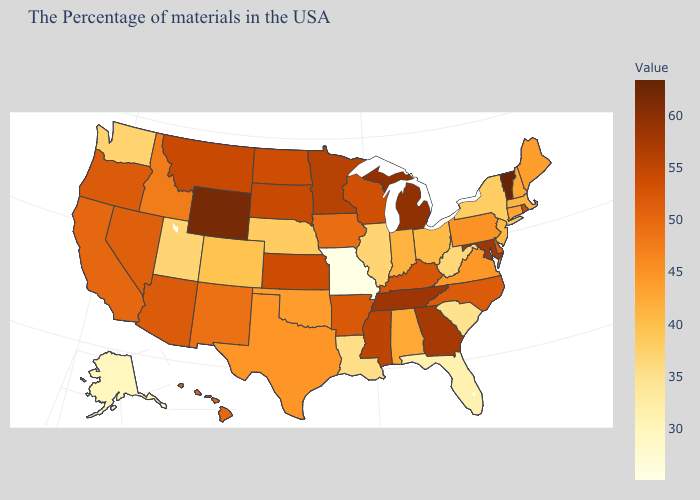Among the states that border Oklahoma , does Colorado have the highest value?
Write a very short answer. No. Among the states that border Montana , does Wyoming have the lowest value?
Concise answer only. No. Among the states that border Rhode Island , does Connecticut have the highest value?
Give a very brief answer. Yes. Does the map have missing data?
Concise answer only. No. Which states have the lowest value in the USA?
Be succinct. Missouri. Does Ohio have the highest value in the MidWest?
Answer briefly. No. Among the states that border Arkansas , which have the highest value?
Write a very short answer. Tennessee. Which states have the highest value in the USA?
Keep it brief. Vermont. Does Missouri have the lowest value in the USA?
Concise answer only. Yes. Among the states that border Florida , does Georgia have the lowest value?
Short answer required. No. 